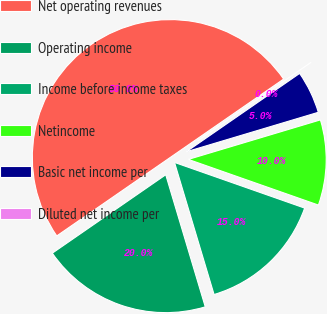Convert chart to OTSL. <chart><loc_0><loc_0><loc_500><loc_500><pie_chart><fcel>Net operating revenues<fcel>Operating income<fcel>Income before income taxes<fcel>Netincome<fcel>Basic net income per<fcel>Diluted net income per<nl><fcel>50.0%<fcel>20.0%<fcel>15.0%<fcel>10.0%<fcel>5.0%<fcel>0.0%<nl></chart> 